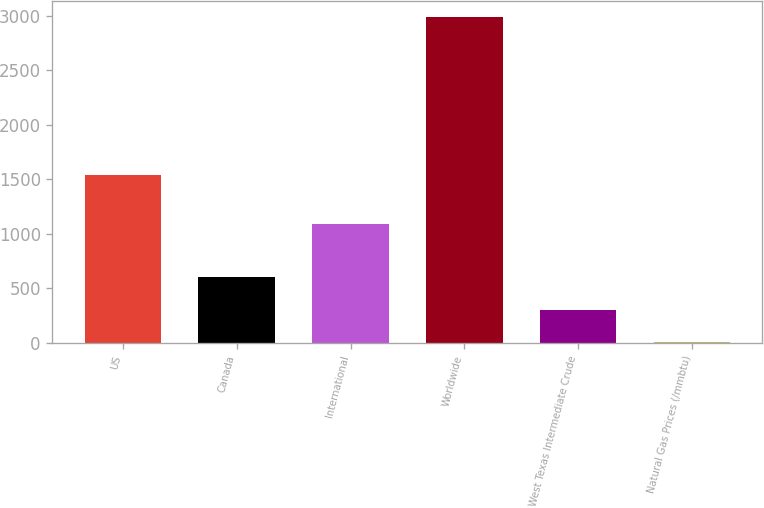<chart> <loc_0><loc_0><loc_500><loc_500><bar_chart><fcel>US<fcel>Canada<fcel>International<fcel>Worldwide<fcel>West Texas Intermediate Crude<fcel>Natural Gas Prices (/mmbtu)<nl><fcel>1541<fcel>600.71<fcel>1094<fcel>2986<fcel>302.55<fcel>4.39<nl></chart> 